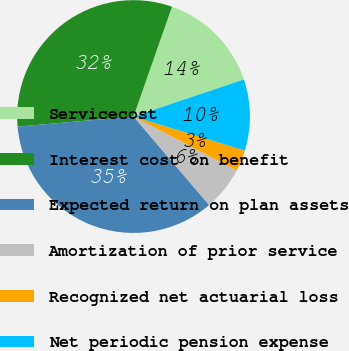Convert chart. <chart><loc_0><loc_0><loc_500><loc_500><pie_chart><fcel>Servicecost<fcel>Interest cost on benefit<fcel>Expected return on plan assets<fcel>Amortization of prior service<fcel>Recognized net actuarial loss<fcel>Net periodic pension expense<nl><fcel>14.48%<fcel>31.74%<fcel>34.88%<fcel>6.08%<fcel>2.94%<fcel>9.88%<nl></chart> 